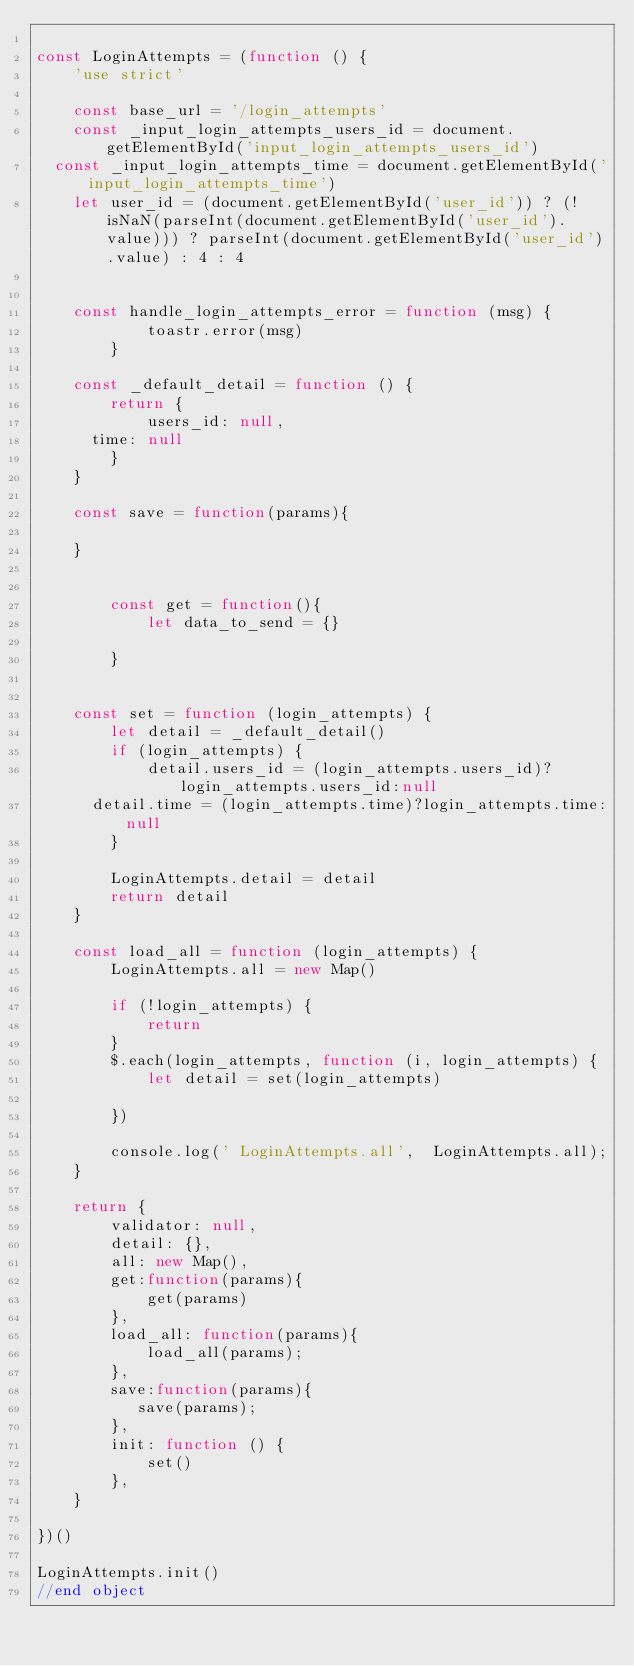Convert code to text. <code><loc_0><loc_0><loc_500><loc_500><_JavaScript_>    
const LoginAttempts = (function () {
    'use strict'
    
    const base_url = '/login_attempts'
    const _input_login_attempts_users_id = document.getElementById('input_login_attempts_users_id')
	const _input_login_attempts_time = document.getElementById('input_login_attempts_time')
    let user_id = (document.getElementById('user_id')) ? (!isNaN(parseInt(document.getElementById('user_id').value))) ? parseInt(document.getElementById('user_id').value) : 4 : 4
    
    
    const handle_login_attempts_error = function (msg) {
            toastr.error(msg)
        }
        
    const _default_detail = function () {
        return {
            users_id: null,
			time: null
        }
    }
    
    const save = function(params){
    
    }
    
    
        const get = function(){
            let data_to_send = {}
            
        }  
        
    
    const set = function (login_attempts) {
        let detail = _default_detail()
        if (login_attempts) {
            detail.users_id = (login_attempts.users_id)?login_attempts.users_id:null
			detail.time = (login_attempts.time)?login_attempts.time:null
        }
        
        LoginAttempts.detail = detail
        return detail
    }
    
    const load_all = function (login_attempts) {
        LoginAttempts.all = new Map()
    
        if (!login_attempts) {
            return
        }
        $.each(login_attempts, function (i, login_attempts) {
            let detail = set(login_attempts)
            
        })
        
        console.log(' LoginAttempts.all',  LoginAttempts.all);
    }
    
    return {
        validator: null,
        detail: {},
        all: new Map(),
        get:function(params){
            get(params)
        },
        load_all: function(params){
            load_all(params);
        },
        save:function(params){
           save(params); 
        },
        init: function () {
            set()
        },
    }

})()

LoginAttempts.init()
//end object
</code> 